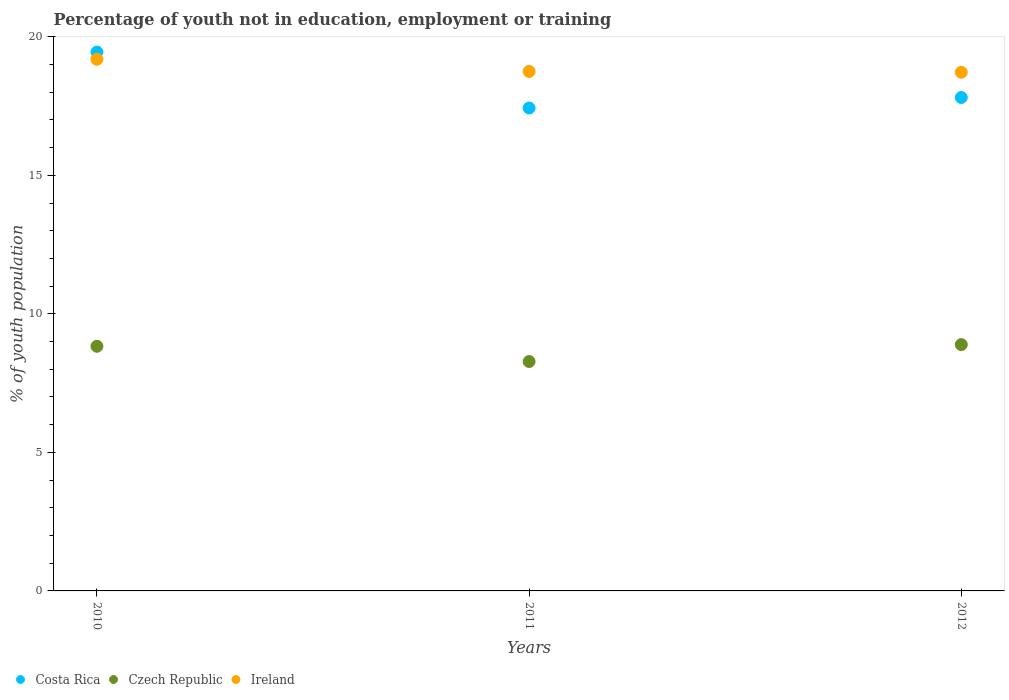How many different coloured dotlines are there?
Provide a succinct answer. 3. What is the percentage of unemployed youth population in in Czech Republic in 2010?
Keep it short and to the point. 8.83. Across all years, what is the maximum percentage of unemployed youth population in in Costa Rica?
Offer a very short reply. 19.45. Across all years, what is the minimum percentage of unemployed youth population in in Czech Republic?
Provide a short and direct response. 8.28. In which year was the percentage of unemployed youth population in in Costa Rica minimum?
Provide a short and direct response. 2011. What is the total percentage of unemployed youth population in in Czech Republic in the graph?
Your answer should be very brief. 26. What is the difference between the percentage of unemployed youth population in in Czech Republic in 2010 and that in 2012?
Your answer should be very brief. -0.06. What is the difference between the percentage of unemployed youth population in in Ireland in 2011 and the percentage of unemployed youth population in in Czech Republic in 2012?
Make the answer very short. 9.86. What is the average percentage of unemployed youth population in in Ireland per year?
Provide a short and direct response. 18.89. In the year 2011, what is the difference between the percentage of unemployed youth population in in Costa Rica and percentage of unemployed youth population in in Ireland?
Give a very brief answer. -1.32. What is the ratio of the percentage of unemployed youth population in in Czech Republic in 2011 to that in 2012?
Offer a very short reply. 0.93. Is the difference between the percentage of unemployed youth population in in Costa Rica in 2010 and 2011 greater than the difference between the percentage of unemployed youth population in in Ireland in 2010 and 2011?
Offer a terse response. Yes. What is the difference between the highest and the second highest percentage of unemployed youth population in in Costa Rica?
Ensure brevity in your answer.  1.64. What is the difference between the highest and the lowest percentage of unemployed youth population in in Costa Rica?
Your answer should be very brief. 2.02. Is it the case that in every year, the sum of the percentage of unemployed youth population in in Czech Republic and percentage of unemployed youth population in in Costa Rica  is greater than the percentage of unemployed youth population in in Ireland?
Keep it short and to the point. Yes. Does the percentage of unemployed youth population in in Ireland monotonically increase over the years?
Provide a short and direct response. No. Is the percentage of unemployed youth population in in Czech Republic strictly greater than the percentage of unemployed youth population in in Ireland over the years?
Make the answer very short. No. Is the percentage of unemployed youth population in in Czech Republic strictly less than the percentage of unemployed youth population in in Ireland over the years?
Your answer should be very brief. Yes. How many years are there in the graph?
Give a very brief answer. 3. Are the values on the major ticks of Y-axis written in scientific E-notation?
Keep it short and to the point. No. Does the graph contain any zero values?
Your answer should be compact. No. Does the graph contain grids?
Offer a very short reply. No. Where does the legend appear in the graph?
Offer a terse response. Bottom left. How many legend labels are there?
Your answer should be very brief. 3. How are the legend labels stacked?
Keep it short and to the point. Horizontal. What is the title of the graph?
Offer a very short reply. Percentage of youth not in education, employment or training. Does "Sudan" appear as one of the legend labels in the graph?
Offer a very short reply. No. What is the label or title of the X-axis?
Give a very brief answer. Years. What is the label or title of the Y-axis?
Give a very brief answer. % of youth population. What is the % of youth population of Costa Rica in 2010?
Make the answer very short. 19.45. What is the % of youth population in Czech Republic in 2010?
Your response must be concise. 8.83. What is the % of youth population in Ireland in 2010?
Provide a short and direct response. 19.19. What is the % of youth population in Costa Rica in 2011?
Provide a short and direct response. 17.43. What is the % of youth population in Czech Republic in 2011?
Give a very brief answer. 8.28. What is the % of youth population in Ireland in 2011?
Give a very brief answer. 18.75. What is the % of youth population of Costa Rica in 2012?
Offer a terse response. 17.81. What is the % of youth population of Czech Republic in 2012?
Give a very brief answer. 8.89. What is the % of youth population of Ireland in 2012?
Give a very brief answer. 18.72. Across all years, what is the maximum % of youth population of Costa Rica?
Provide a short and direct response. 19.45. Across all years, what is the maximum % of youth population in Czech Republic?
Offer a very short reply. 8.89. Across all years, what is the maximum % of youth population of Ireland?
Provide a short and direct response. 19.19. Across all years, what is the minimum % of youth population in Costa Rica?
Offer a very short reply. 17.43. Across all years, what is the minimum % of youth population in Czech Republic?
Offer a terse response. 8.28. Across all years, what is the minimum % of youth population in Ireland?
Ensure brevity in your answer.  18.72. What is the total % of youth population of Costa Rica in the graph?
Ensure brevity in your answer.  54.69. What is the total % of youth population of Czech Republic in the graph?
Offer a very short reply. 26. What is the total % of youth population of Ireland in the graph?
Ensure brevity in your answer.  56.66. What is the difference between the % of youth population in Costa Rica in 2010 and that in 2011?
Your response must be concise. 2.02. What is the difference between the % of youth population in Czech Republic in 2010 and that in 2011?
Your answer should be compact. 0.55. What is the difference between the % of youth population in Ireland in 2010 and that in 2011?
Offer a very short reply. 0.44. What is the difference between the % of youth population of Costa Rica in 2010 and that in 2012?
Give a very brief answer. 1.64. What is the difference between the % of youth population of Czech Republic in 2010 and that in 2012?
Your answer should be compact. -0.06. What is the difference between the % of youth population in Ireland in 2010 and that in 2012?
Your answer should be compact. 0.47. What is the difference between the % of youth population of Costa Rica in 2011 and that in 2012?
Give a very brief answer. -0.38. What is the difference between the % of youth population in Czech Republic in 2011 and that in 2012?
Offer a terse response. -0.61. What is the difference between the % of youth population of Costa Rica in 2010 and the % of youth population of Czech Republic in 2011?
Ensure brevity in your answer.  11.17. What is the difference between the % of youth population of Czech Republic in 2010 and the % of youth population of Ireland in 2011?
Offer a very short reply. -9.92. What is the difference between the % of youth population in Costa Rica in 2010 and the % of youth population in Czech Republic in 2012?
Ensure brevity in your answer.  10.56. What is the difference between the % of youth population of Costa Rica in 2010 and the % of youth population of Ireland in 2012?
Offer a terse response. 0.73. What is the difference between the % of youth population of Czech Republic in 2010 and the % of youth population of Ireland in 2012?
Your response must be concise. -9.89. What is the difference between the % of youth population in Costa Rica in 2011 and the % of youth population in Czech Republic in 2012?
Keep it short and to the point. 8.54. What is the difference between the % of youth population of Costa Rica in 2011 and the % of youth population of Ireland in 2012?
Your answer should be compact. -1.29. What is the difference between the % of youth population in Czech Republic in 2011 and the % of youth population in Ireland in 2012?
Your answer should be compact. -10.44. What is the average % of youth population in Costa Rica per year?
Provide a short and direct response. 18.23. What is the average % of youth population of Czech Republic per year?
Offer a very short reply. 8.67. What is the average % of youth population in Ireland per year?
Your answer should be compact. 18.89. In the year 2010, what is the difference between the % of youth population in Costa Rica and % of youth population in Czech Republic?
Offer a terse response. 10.62. In the year 2010, what is the difference between the % of youth population of Costa Rica and % of youth population of Ireland?
Keep it short and to the point. 0.26. In the year 2010, what is the difference between the % of youth population in Czech Republic and % of youth population in Ireland?
Offer a terse response. -10.36. In the year 2011, what is the difference between the % of youth population of Costa Rica and % of youth population of Czech Republic?
Offer a terse response. 9.15. In the year 2011, what is the difference between the % of youth population of Costa Rica and % of youth population of Ireland?
Your response must be concise. -1.32. In the year 2011, what is the difference between the % of youth population in Czech Republic and % of youth population in Ireland?
Your response must be concise. -10.47. In the year 2012, what is the difference between the % of youth population of Costa Rica and % of youth population of Czech Republic?
Your response must be concise. 8.92. In the year 2012, what is the difference between the % of youth population in Costa Rica and % of youth population in Ireland?
Provide a succinct answer. -0.91. In the year 2012, what is the difference between the % of youth population of Czech Republic and % of youth population of Ireland?
Give a very brief answer. -9.83. What is the ratio of the % of youth population of Costa Rica in 2010 to that in 2011?
Your response must be concise. 1.12. What is the ratio of the % of youth population in Czech Republic in 2010 to that in 2011?
Your answer should be compact. 1.07. What is the ratio of the % of youth population in Ireland in 2010 to that in 2011?
Keep it short and to the point. 1.02. What is the ratio of the % of youth population of Costa Rica in 2010 to that in 2012?
Offer a very short reply. 1.09. What is the ratio of the % of youth population in Ireland in 2010 to that in 2012?
Make the answer very short. 1.03. What is the ratio of the % of youth population in Costa Rica in 2011 to that in 2012?
Your answer should be very brief. 0.98. What is the ratio of the % of youth population of Czech Republic in 2011 to that in 2012?
Your answer should be very brief. 0.93. What is the difference between the highest and the second highest % of youth population of Costa Rica?
Your answer should be very brief. 1.64. What is the difference between the highest and the second highest % of youth population in Czech Republic?
Offer a terse response. 0.06. What is the difference between the highest and the second highest % of youth population in Ireland?
Provide a short and direct response. 0.44. What is the difference between the highest and the lowest % of youth population in Costa Rica?
Provide a short and direct response. 2.02. What is the difference between the highest and the lowest % of youth population of Czech Republic?
Offer a very short reply. 0.61. What is the difference between the highest and the lowest % of youth population in Ireland?
Your response must be concise. 0.47. 